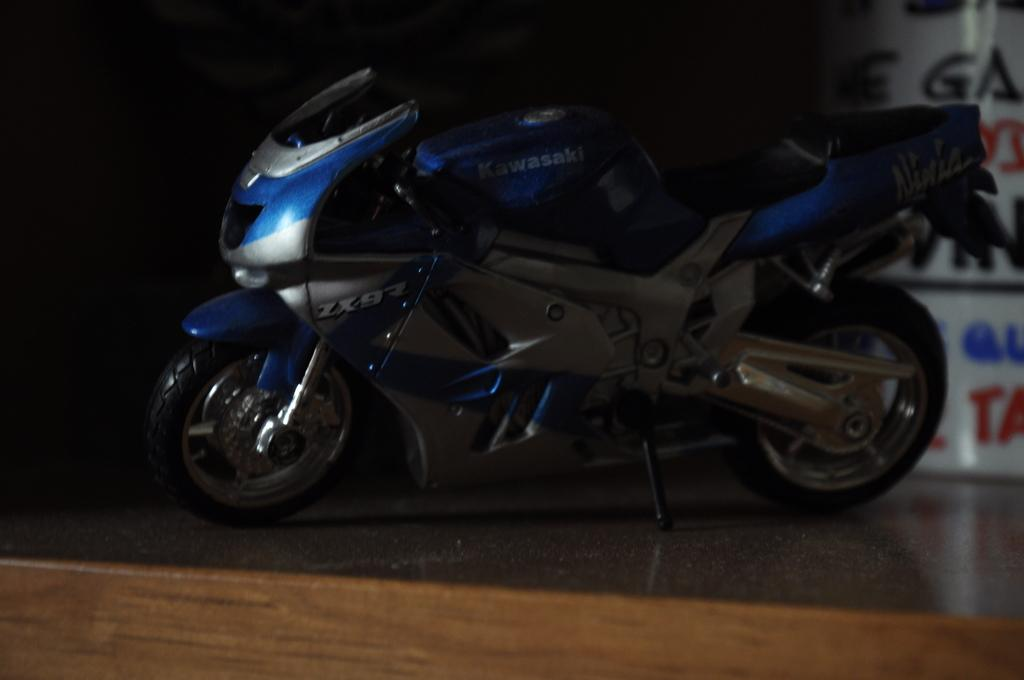What is the main object in the image? There is a bike in the image. Where is the bike located? The bike is on the floor. What else can be seen on the right side of the image? There is a board with text on the right side of the image. What type of wound can be seen on the bike's tire in the image? There is no wound visible on the bike's tire in the image. What thought is expressed on the board with text in the image? The provided facts do not mention the content of the text on the board, so we cannot determine the thought expressed. 